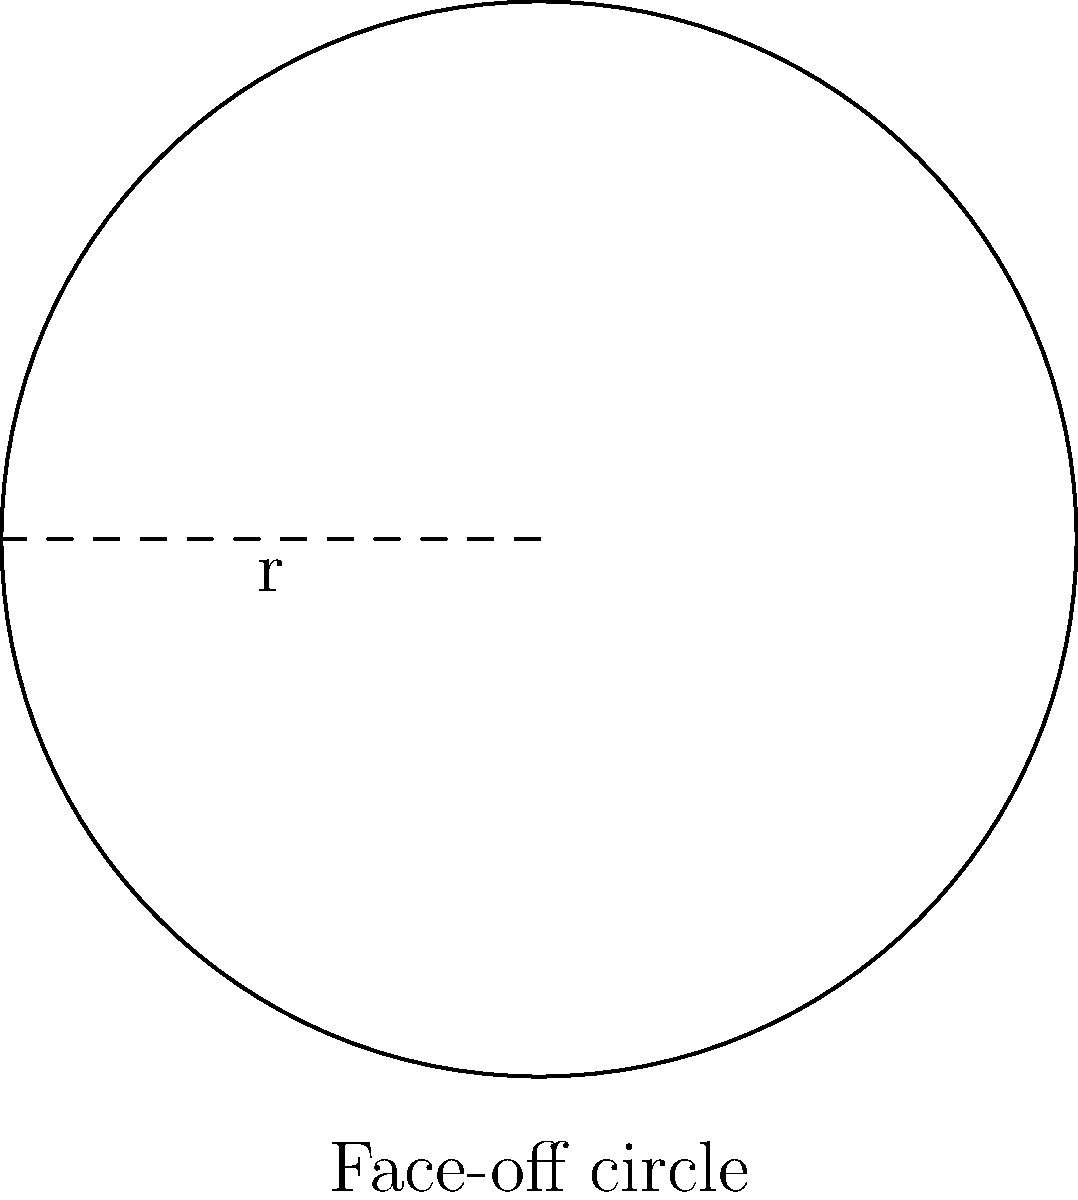In an ice hockey rink, the face-off circle has a radius of 4.5 meters. What is the area of this face-off circle? To find the area of the face-off circle, we need to use the formula for the area of a circle:

$$A = \pi r^2$$

Where:
$A$ is the area of the circle
$\pi$ (pi) is approximately 3.14159
$r$ is the radius of the circle

Given:
Radius $(r) = 4.5$ meters

Let's substitute these values into the formula:

$$A = \pi (4.5)^2$$

Now, let's calculate:

1) First, square the radius:
   $4.5^2 = 20.25$

2) Then multiply by $\pi$:
   $A = \pi \times 20.25 \approx 3.14159 \times 20.25 \approx 63.62$ square meters

Therefore, the area of the face-off circle is approximately 63.62 square meters.
Answer: $63.62$ m² 